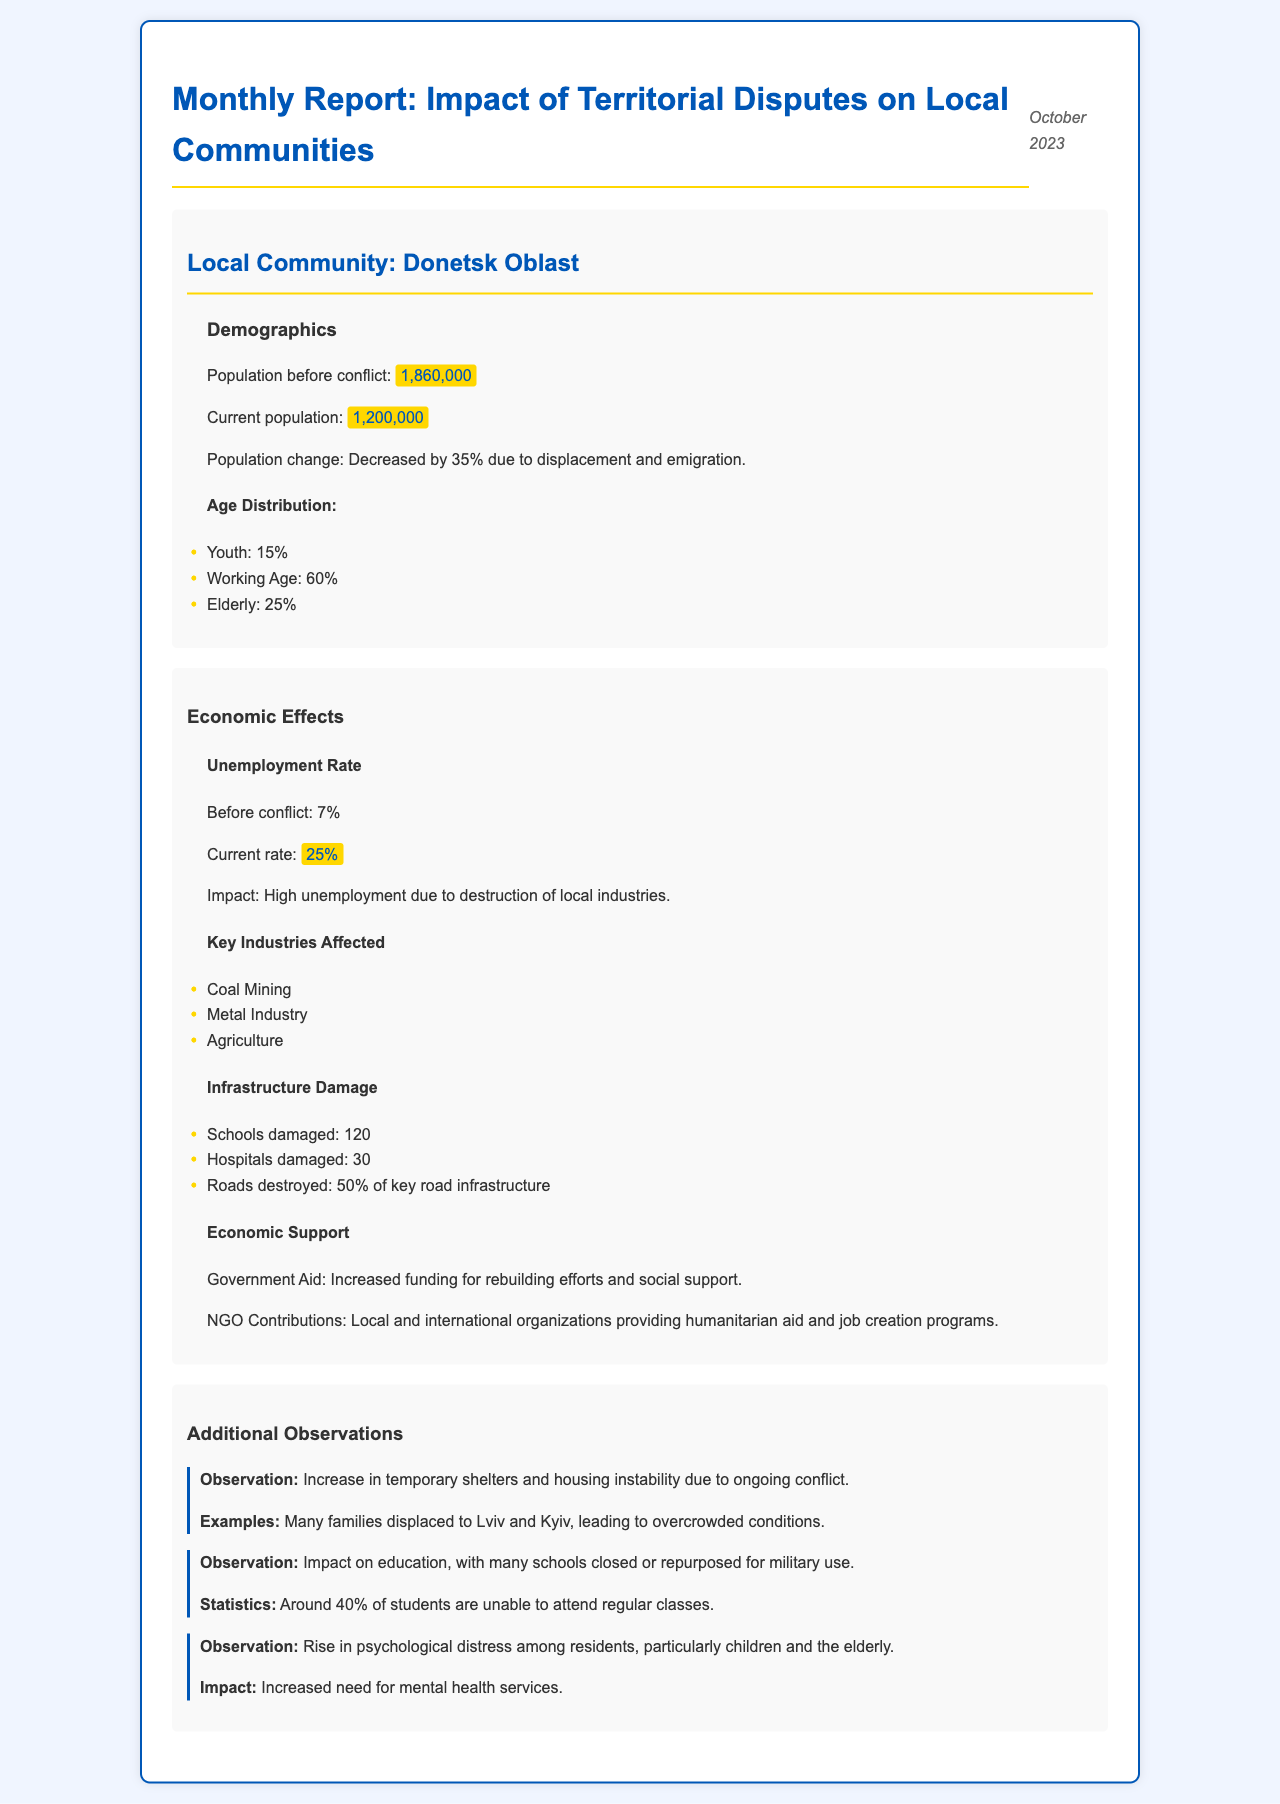what was the population before the conflict in Donetsk Oblast? The population before the conflict is explicitly stated in the demographics section of the document.
Answer: 1,860,000 what is the current unemployment rate in Donetsk Oblast? The current unemployment rate is provided in the economic effects section of the document.
Answer: 25% how much has the population decreased by? The document specifies the percentage decrease in population due to displacement and emigration.
Answer: 35% how many hospitals were damaged? The number of damaged hospitals is listed under infrastructure damage in the economic effects section.
Answer: 30 what key industry is affected apart from coal mining? The document lists multiple key industries affected, requiring recall of one aside from the first mentioned.
Answer: Metal Industry how many students are unable to attend regular classes in Donetsk Oblast? The document shows the percentage of students unable to attend classes due to the impact of education.
Answer: 40% what type of observation describes the rise in psychological distress? The observation section mentions an increase in a particular demographic's psychological distress.
Answer: Children and the elderly what is the government aid mentioned in the document? The document provides a summary of the government support being discussed in the economic effects section.
Answer: Increased funding for rebuilding efforts and social support 